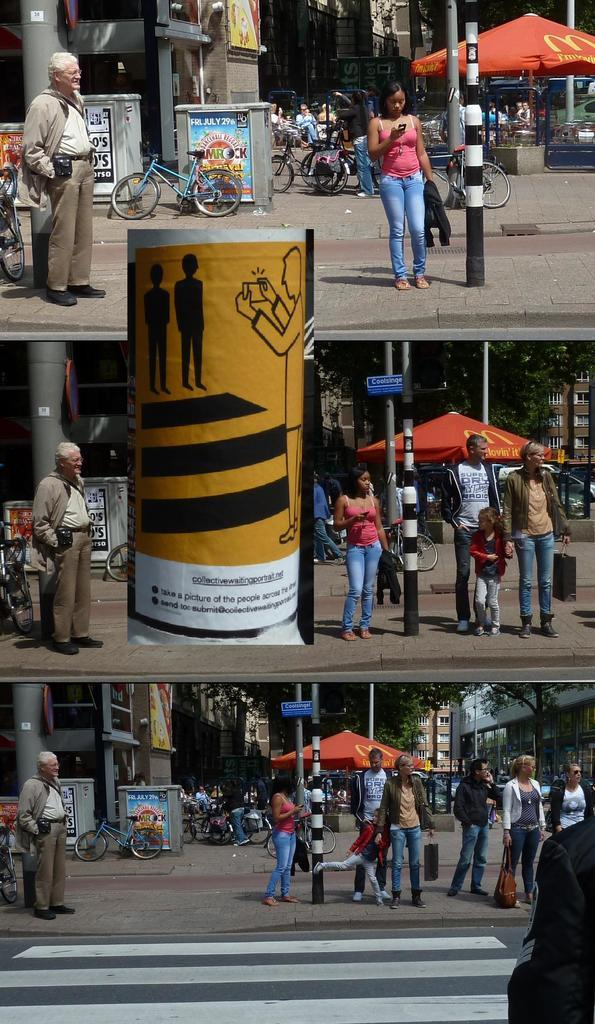<image>
Summarize the visual content of the image. Three photographs show a street with a blue sign indicating its name, Coolsingel. 